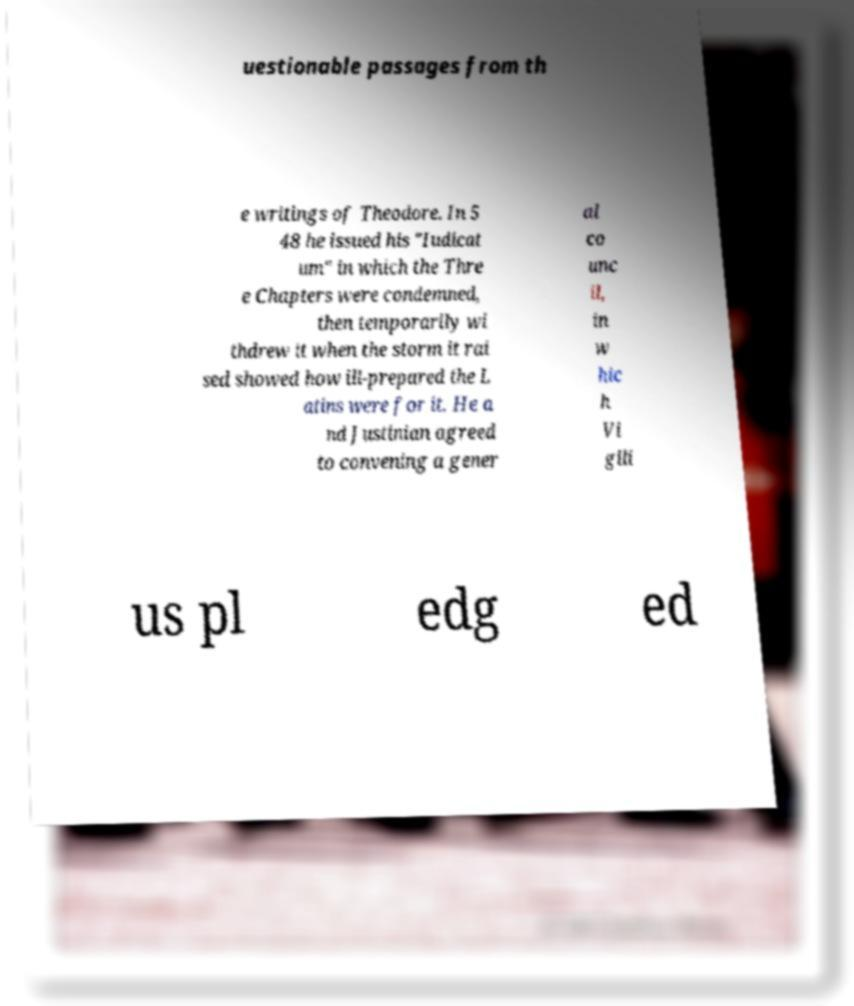Could you extract and type out the text from this image? uestionable passages from th e writings of Theodore. In 5 48 he issued his "Iudicat um" in which the Thre e Chapters were condemned, then temporarily wi thdrew it when the storm it rai sed showed how ill-prepared the L atins were for it. He a nd Justinian agreed to convening a gener al co unc il, in w hic h Vi gili us pl edg ed 